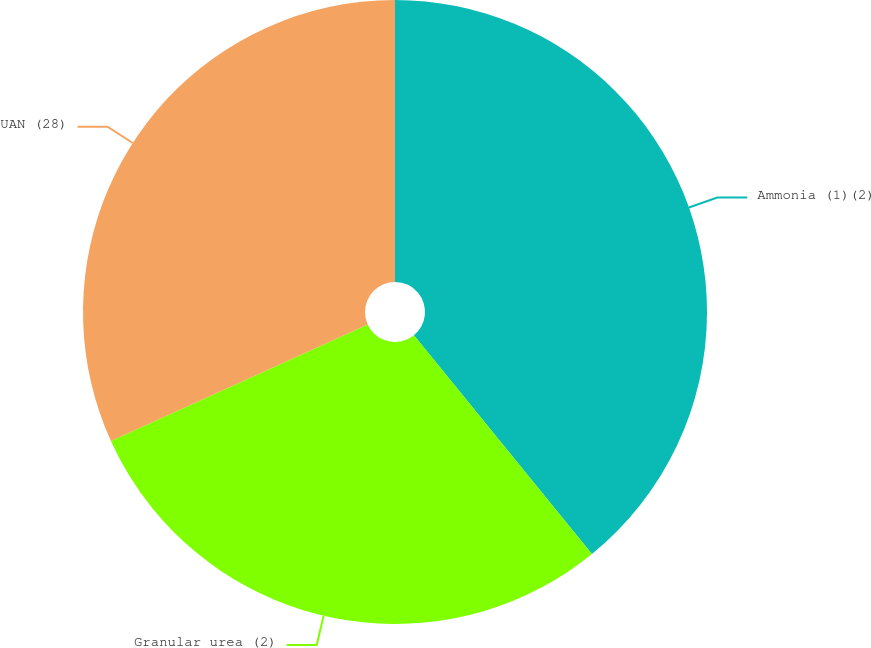Convert chart to OTSL. <chart><loc_0><loc_0><loc_500><loc_500><pie_chart><fcel>Ammonia (1)(2)<fcel>Granular urea (2)<fcel>UAN (28)<nl><fcel>39.13%<fcel>29.09%<fcel>31.78%<nl></chart> 